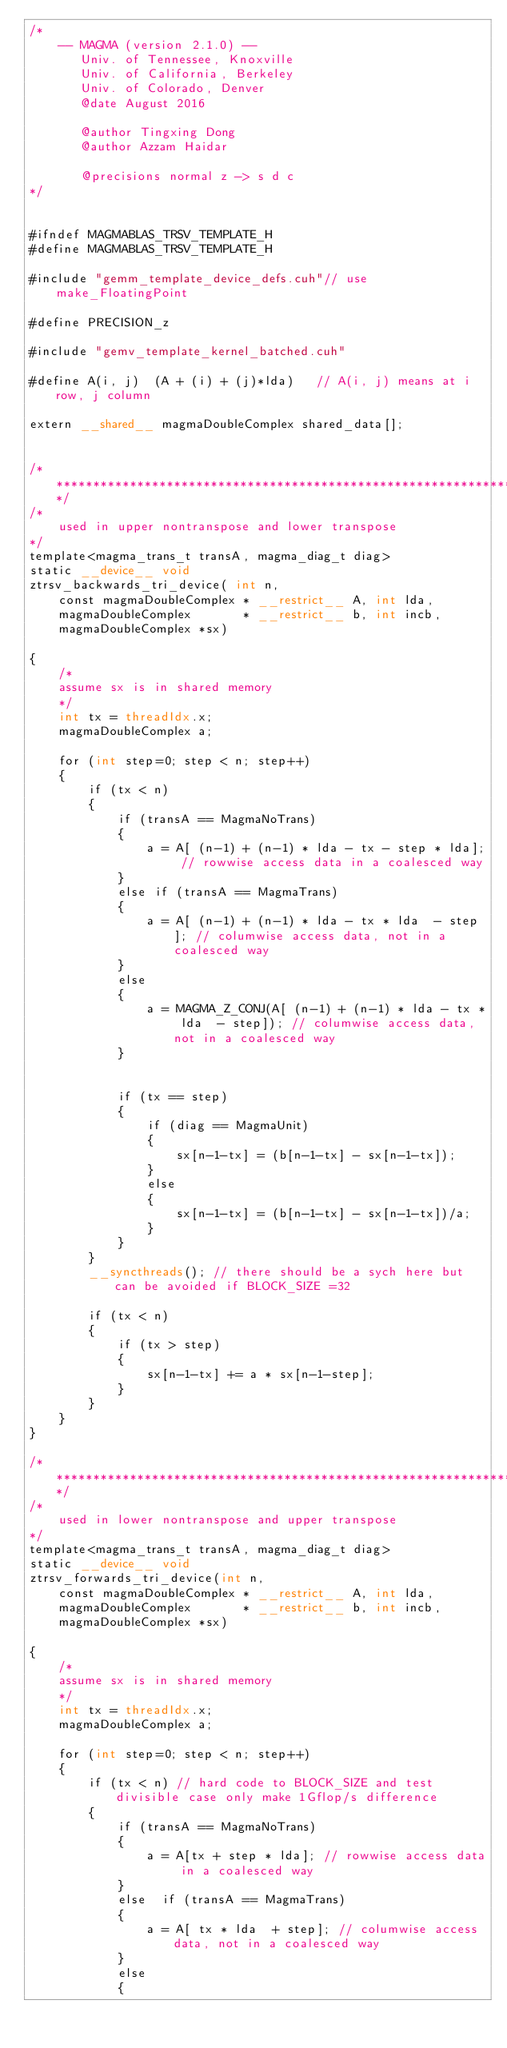Convert code to text. <code><loc_0><loc_0><loc_500><loc_500><_Cuda_>/*
    -- MAGMA (version 2.1.0) --
       Univ. of Tennessee, Knoxville
       Univ. of California, Berkeley
       Univ. of Colorado, Denver
       @date August 2016

       @author Tingxing Dong
       @author Azzam Haidar

       @precisions normal z -> s d c
*/


#ifndef MAGMABLAS_TRSV_TEMPLATE_H
#define MAGMABLAS_TRSV_TEMPLATE_H

#include "gemm_template_device_defs.cuh"// use make_FloatingPoint

#define PRECISION_z

#include "gemv_template_kernel_batched.cuh"

#define A(i, j)  (A + (i) + (j)*lda)   // A(i, j) means at i row, j column

extern __shared__ magmaDoubleComplex shared_data[];


/******************************************************************************/
/*
    used in upper nontranspose and lower transpose
*/
template<magma_trans_t transA, magma_diag_t diag>
static __device__ void
ztrsv_backwards_tri_device( int n,
    const magmaDoubleComplex * __restrict__ A, int lda,
    magmaDoubleComplex       * __restrict__ b, int incb,
    magmaDoubleComplex *sx)

{
    /*
    assume sx is in shared memory
    */
    int tx = threadIdx.x;
    magmaDoubleComplex a;

    for (int step=0; step < n; step++)
    {
        if (tx < n)
        {
            if (transA == MagmaNoTrans)
            {
                a = A[ (n-1) + (n-1) * lda - tx - step * lda]; // rowwise access data in a coalesced way
            }
            else if (transA == MagmaTrans)
            {
                a = A[ (n-1) + (n-1) * lda - tx * lda  - step]; // columwise access data, not in a coalesced way
            }
            else
            {
                a = MAGMA_Z_CONJ(A[ (n-1) + (n-1) * lda - tx * lda  - step]); // columwise access data, not in a coalesced way
            }


            if (tx == step)
            {
                if (diag == MagmaUnit)
                {
                    sx[n-1-tx] = (b[n-1-tx] - sx[n-1-tx]);
                }
                else
                {
                    sx[n-1-tx] = (b[n-1-tx] - sx[n-1-tx])/a;
                }
            }
        }
        __syncthreads(); // there should be a sych here but can be avoided if BLOCK_SIZE =32

        if (tx < n)
        {
            if (tx > step)
            {
                sx[n-1-tx] += a * sx[n-1-step];
            }
        }
    }
}

/******************************************************************************/
/*
    used in lower nontranspose and upper transpose
*/
template<magma_trans_t transA, magma_diag_t diag>
static __device__ void
ztrsv_forwards_tri_device(int n,
    const magmaDoubleComplex * __restrict__ A, int lda,
    magmaDoubleComplex       * __restrict__ b, int incb,
    magmaDoubleComplex *sx)

{
    /*
    assume sx is in shared memory
    */
    int tx = threadIdx.x;
    magmaDoubleComplex a;

    for (int step=0; step < n; step++)
    {
        if (tx < n) // hard code to BLOCK_SIZE and test divisible case only make 1Gflop/s difference
        {
            if (transA == MagmaNoTrans)
            {
                a = A[tx + step * lda]; // rowwise access data in a coalesced way
            }
            else  if (transA == MagmaTrans)
            {
                a = A[ tx * lda  + step]; // columwise access data, not in a coalesced way
            }
            else
            {</code> 